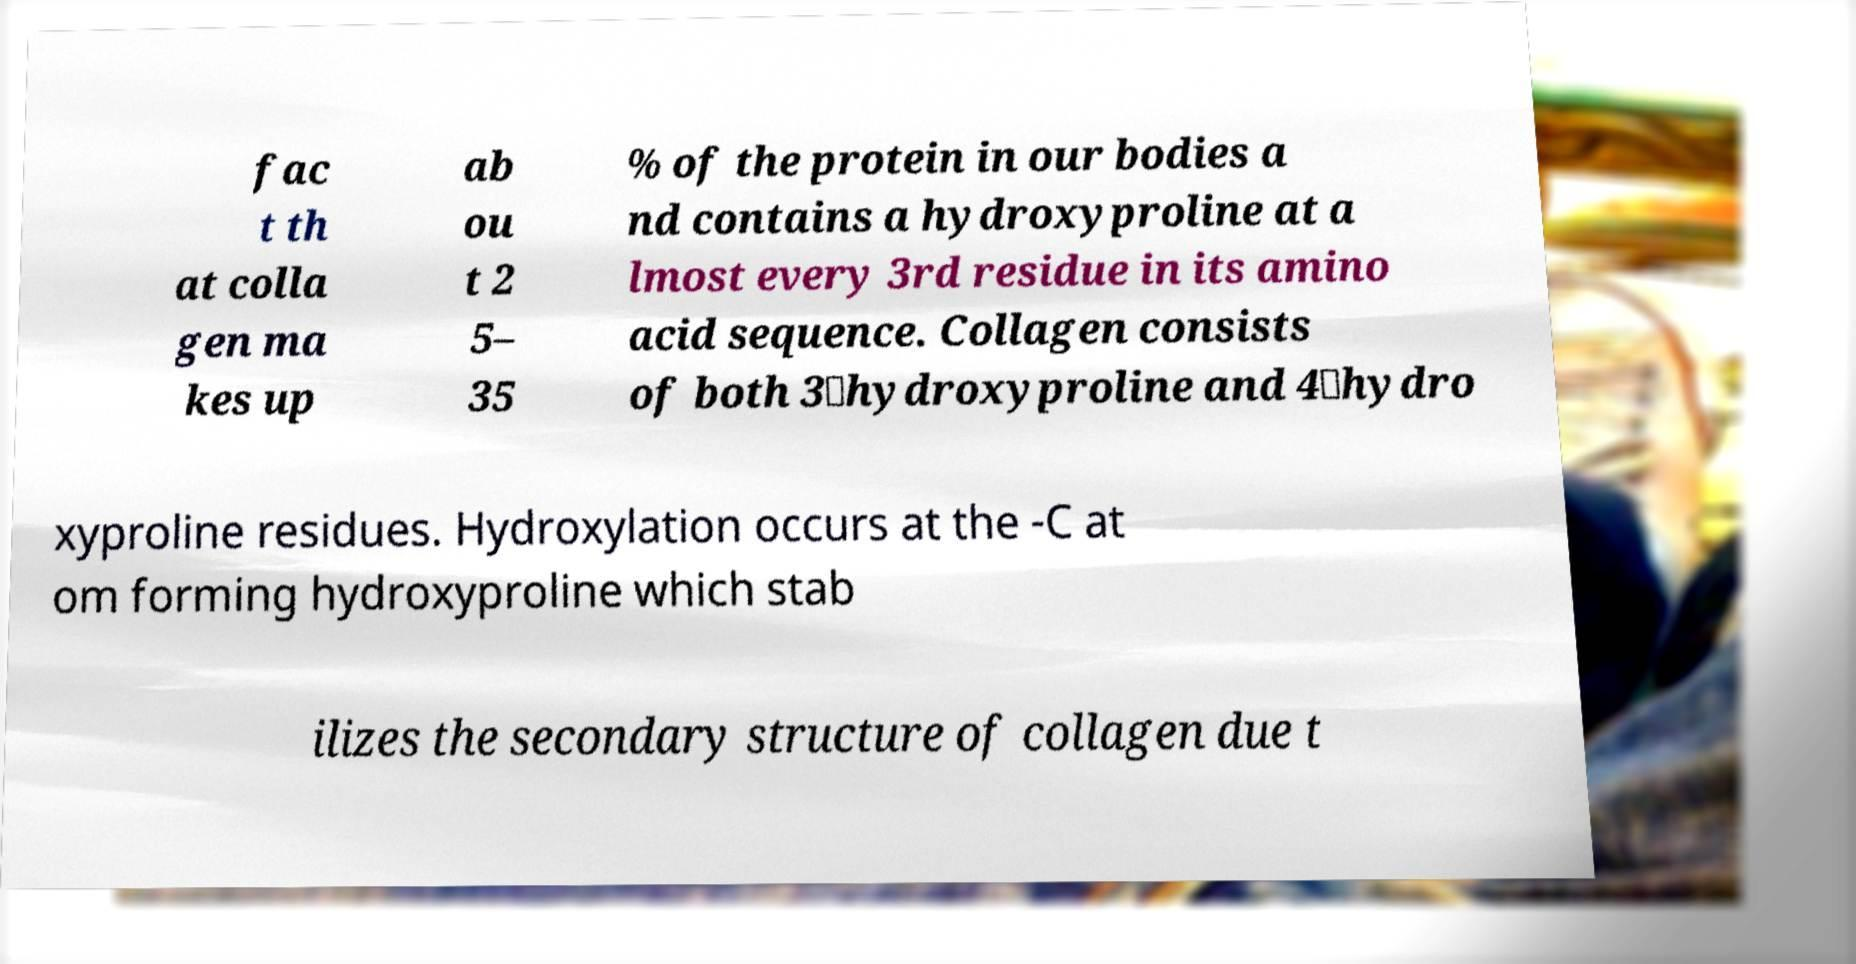Please read and relay the text visible in this image. What does it say? fac t th at colla gen ma kes up ab ou t 2 5– 35 % of the protein in our bodies a nd contains a hydroxyproline at a lmost every 3rd residue in its amino acid sequence. Collagen consists of both 3‐hydroxyproline and 4‐hydro xyproline residues. Hydroxylation occurs at the -C at om forming hydroxyproline which stab ilizes the secondary structure of collagen due t 